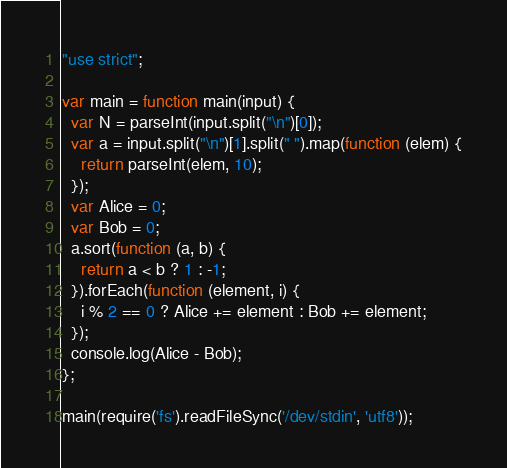Convert code to text. <code><loc_0><loc_0><loc_500><loc_500><_JavaScript_>"use strict";

var main = function main(input) {
  var N = parseInt(input.split("\n")[0]);
  var a = input.split("\n")[1].split(" ").map(function (elem) {
    return parseInt(elem, 10);
  });
  var Alice = 0;
  var Bob = 0;
  a.sort(function (a, b) {
    return a < b ? 1 : -1;
  }).forEach(function (element, i) {
    i % 2 == 0 ? Alice += element : Bob += element;
  });
  console.log(Alice - Bob);
};

main(require('fs').readFileSync('/dev/stdin', 'utf8'));</code> 